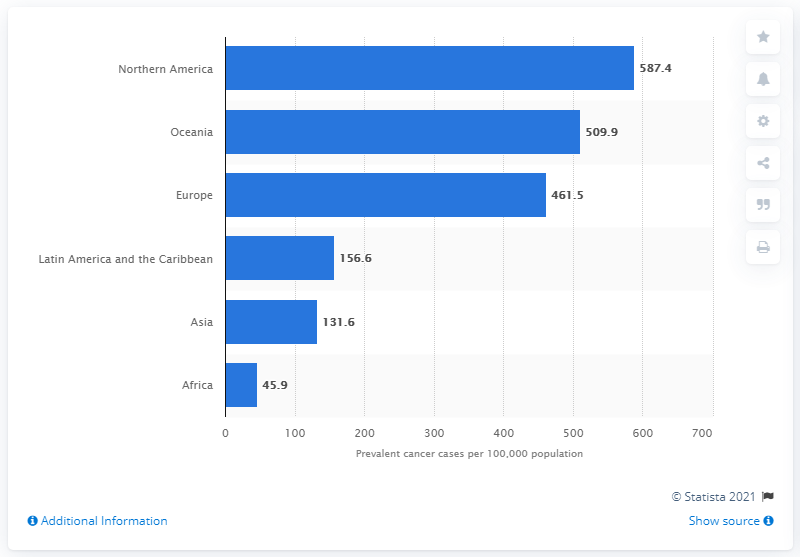Give some essential details in this illustration. In North and South America, a total of 744 cases were contributed. The area with the highest number of cases is Northern America. 